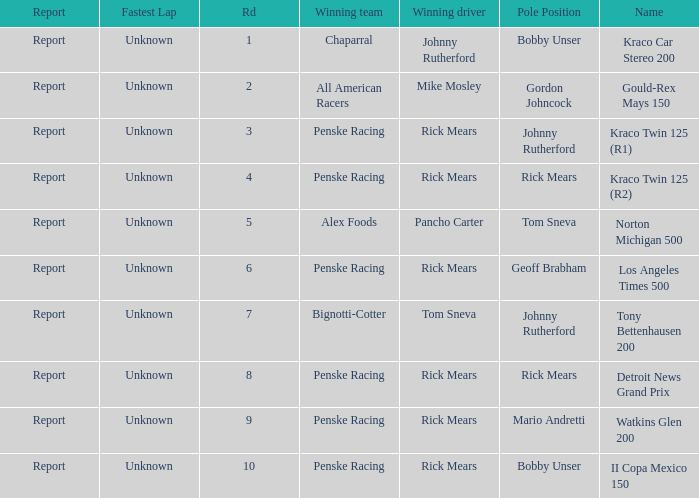What are the races that johnny rutherford has won? Kraco Car Stereo 200. 